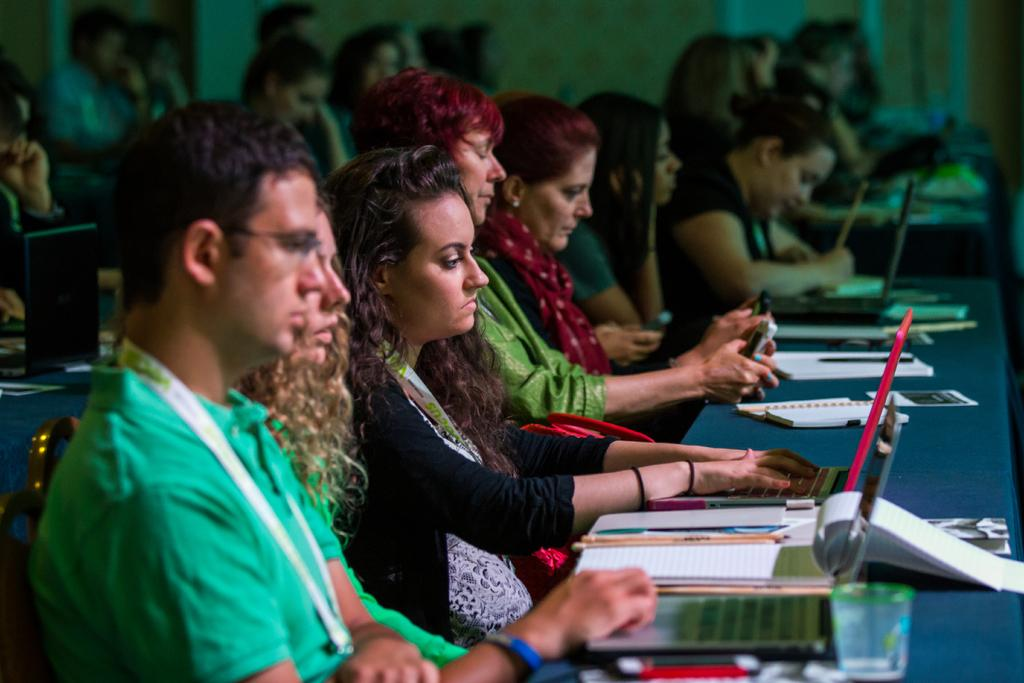What are the people in the image doing? The people in the image are sitting. How can you describe the clothing of the people in the image? The people are wearing different color dresses. What electronic devices can be seen in the image? There are laptops visible in the image. What type of reading material is present in the image? There are books in the image. What objects can be found on the tables in the image? There are objects on the tables. Can you describe the background of the image? The background of the image is blurred. What type of butter can be seen on the seashore in the image? There is no seashore or butter present in the image. What kind of paste is being used by the people in the image? There is no paste being used by the people in the image. 